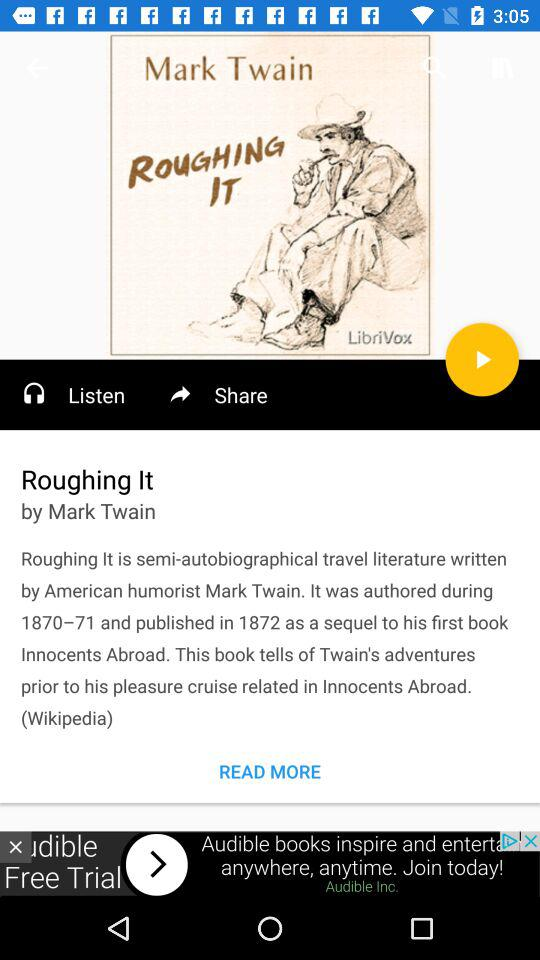What is the title of the book? The title is "Roughing It". 